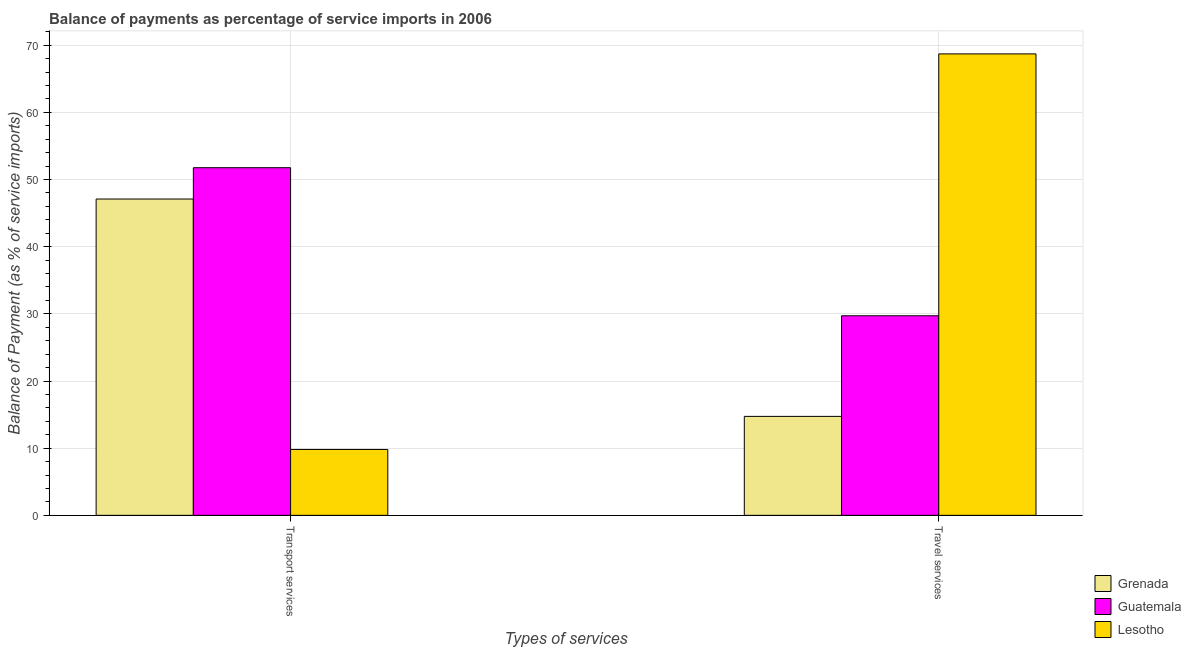How many groups of bars are there?
Your answer should be compact. 2. Are the number of bars on each tick of the X-axis equal?
Give a very brief answer. Yes. How many bars are there on the 1st tick from the left?
Offer a terse response. 3. What is the label of the 1st group of bars from the left?
Keep it short and to the point. Transport services. What is the balance of payments of travel services in Grenada?
Give a very brief answer. 14.74. Across all countries, what is the maximum balance of payments of transport services?
Keep it short and to the point. 51.76. Across all countries, what is the minimum balance of payments of travel services?
Ensure brevity in your answer.  14.74. In which country was the balance of payments of travel services maximum?
Offer a very short reply. Lesotho. In which country was the balance of payments of travel services minimum?
Offer a terse response. Grenada. What is the total balance of payments of transport services in the graph?
Make the answer very short. 108.67. What is the difference between the balance of payments of travel services in Guatemala and that in Lesotho?
Offer a terse response. -38.99. What is the difference between the balance of payments of transport services in Lesotho and the balance of payments of travel services in Guatemala?
Your answer should be very brief. -19.91. What is the average balance of payments of transport services per country?
Provide a succinct answer. 36.22. What is the difference between the balance of payments of transport services and balance of payments of travel services in Guatemala?
Provide a short and direct response. 22.04. What is the ratio of the balance of payments of transport services in Grenada to that in Lesotho?
Your answer should be very brief. 4.8. Is the balance of payments of travel services in Guatemala less than that in Lesotho?
Your answer should be compact. Yes. In how many countries, is the balance of payments of transport services greater than the average balance of payments of transport services taken over all countries?
Your answer should be very brief. 2. What does the 3rd bar from the left in Transport services represents?
Your response must be concise. Lesotho. What does the 2nd bar from the right in Transport services represents?
Give a very brief answer. Guatemala. How many countries are there in the graph?
Provide a succinct answer. 3. Does the graph contain any zero values?
Keep it short and to the point. No. Does the graph contain grids?
Provide a short and direct response. Yes. Where does the legend appear in the graph?
Offer a very short reply. Bottom right. How many legend labels are there?
Make the answer very short. 3. What is the title of the graph?
Your answer should be very brief. Balance of payments as percentage of service imports in 2006. What is the label or title of the X-axis?
Give a very brief answer. Types of services. What is the label or title of the Y-axis?
Your answer should be compact. Balance of Payment (as % of service imports). What is the Balance of Payment (as % of service imports) in Grenada in Transport services?
Your answer should be very brief. 47.1. What is the Balance of Payment (as % of service imports) in Guatemala in Transport services?
Your response must be concise. 51.76. What is the Balance of Payment (as % of service imports) of Lesotho in Transport services?
Offer a terse response. 9.81. What is the Balance of Payment (as % of service imports) in Grenada in Travel services?
Provide a short and direct response. 14.74. What is the Balance of Payment (as % of service imports) in Guatemala in Travel services?
Provide a short and direct response. 29.72. What is the Balance of Payment (as % of service imports) of Lesotho in Travel services?
Give a very brief answer. 68.71. Across all Types of services, what is the maximum Balance of Payment (as % of service imports) of Grenada?
Your response must be concise. 47.1. Across all Types of services, what is the maximum Balance of Payment (as % of service imports) in Guatemala?
Your answer should be compact. 51.76. Across all Types of services, what is the maximum Balance of Payment (as % of service imports) in Lesotho?
Your answer should be compact. 68.71. Across all Types of services, what is the minimum Balance of Payment (as % of service imports) in Grenada?
Give a very brief answer. 14.74. Across all Types of services, what is the minimum Balance of Payment (as % of service imports) of Guatemala?
Give a very brief answer. 29.72. Across all Types of services, what is the minimum Balance of Payment (as % of service imports) of Lesotho?
Your response must be concise. 9.81. What is the total Balance of Payment (as % of service imports) in Grenada in the graph?
Make the answer very short. 61.83. What is the total Balance of Payment (as % of service imports) in Guatemala in the graph?
Provide a succinct answer. 81.48. What is the total Balance of Payment (as % of service imports) in Lesotho in the graph?
Provide a succinct answer. 78.52. What is the difference between the Balance of Payment (as % of service imports) of Grenada in Transport services and that in Travel services?
Offer a very short reply. 32.36. What is the difference between the Balance of Payment (as % of service imports) in Guatemala in Transport services and that in Travel services?
Provide a short and direct response. 22.04. What is the difference between the Balance of Payment (as % of service imports) in Lesotho in Transport services and that in Travel services?
Give a very brief answer. -58.9. What is the difference between the Balance of Payment (as % of service imports) of Grenada in Transport services and the Balance of Payment (as % of service imports) of Guatemala in Travel services?
Offer a very short reply. 17.38. What is the difference between the Balance of Payment (as % of service imports) in Grenada in Transport services and the Balance of Payment (as % of service imports) in Lesotho in Travel services?
Your response must be concise. -21.61. What is the difference between the Balance of Payment (as % of service imports) of Guatemala in Transport services and the Balance of Payment (as % of service imports) of Lesotho in Travel services?
Give a very brief answer. -16.95. What is the average Balance of Payment (as % of service imports) of Grenada per Types of services?
Ensure brevity in your answer.  30.92. What is the average Balance of Payment (as % of service imports) in Guatemala per Types of services?
Your answer should be compact. 40.74. What is the average Balance of Payment (as % of service imports) of Lesotho per Types of services?
Your response must be concise. 39.26. What is the difference between the Balance of Payment (as % of service imports) of Grenada and Balance of Payment (as % of service imports) of Guatemala in Transport services?
Provide a short and direct response. -4.66. What is the difference between the Balance of Payment (as % of service imports) in Grenada and Balance of Payment (as % of service imports) in Lesotho in Transport services?
Provide a succinct answer. 37.29. What is the difference between the Balance of Payment (as % of service imports) of Guatemala and Balance of Payment (as % of service imports) of Lesotho in Transport services?
Provide a succinct answer. 41.95. What is the difference between the Balance of Payment (as % of service imports) in Grenada and Balance of Payment (as % of service imports) in Guatemala in Travel services?
Give a very brief answer. -14.98. What is the difference between the Balance of Payment (as % of service imports) of Grenada and Balance of Payment (as % of service imports) of Lesotho in Travel services?
Offer a very short reply. -53.97. What is the difference between the Balance of Payment (as % of service imports) in Guatemala and Balance of Payment (as % of service imports) in Lesotho in Travel services?
Ensure brevity in your answer.  -38.99. What is the ratio of the Balance of Payment (as % of service imports) in Grenada in Transport services to that in Travel services?
Keep it short and to the point. 3.2. What is the ratio of the Balance of Payment (as % of service imports) in Guatemala in Transport services to that in Travel services?
Your response must be concise. 1.74. What is the ratio of the Balance of Payment (as % of service imports) of Lesotho in Transport services to that in Travel services?
Provide a succinct answer. 0.14. What is the difference between the highest and the second highest Balance of Payment (as % of service imports) in Grenada?
Offer a very short reply. 32.36. What is the difference between the highest and the second highest Balance of Payment (as % of service imports) of Guatemala?
Provide a succinct answer. 22.04. What is the difference between the highest and the second highest Balance of Payment (as % of service imports) of Lesotho?
Your answer should be compact. 58.9. What is the difference between the highest and the lowest Balance of Payment (as % of service imports) in Grenada?
Your response must be concise. 32.36. What is the difference between the highest and the lowest Balance of Payment (as % of service imports) in Guatemala?
Offer a terse response. 22.04. What is the difference between the highest and the lowest Balance of Payment (as % of service imports) of Lesotho?
Keep it short and to the point. 58.9. 